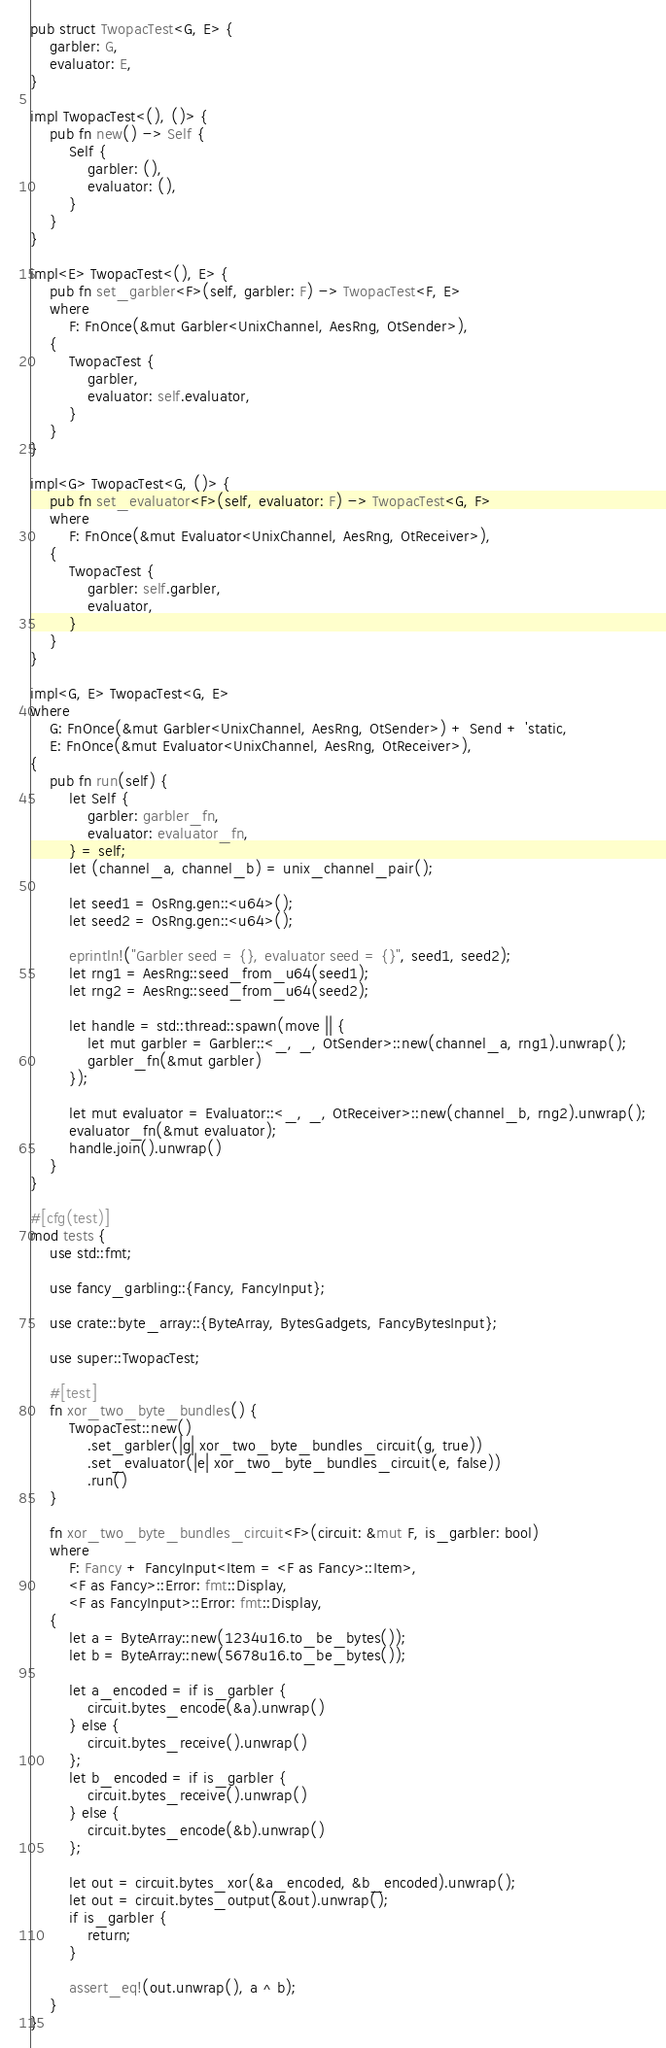Convert code to text. <code><loc_0><loc_0><loc_500><loc_500><_Rust_>pub struct TwopacTest<G, E> {
    garbler: G,
    evaluator: E,
}

impl TwopacTest<(), ()> {
    pub fn new() -> Self {
        Self {
            garbler: (),
            evaluator: (),
        }
    }
}

impl<E> TwopacTest<(), E> {
    pub fn set_garbler<F>(self, garbler: F) -> TwopacTest<F, E>
    where
        F: FnOnce(&mut Garbler<UnixChannel, AesRng, OtSender>),
    {
        TwopacTest {
            garbler,
            evaluator: self.evaluator,
        }
    }
}

impl<G> TwopacTest<G, ()> {
    pub fn set_evaluator<F>(self, evaluator: F) -> TwopacTest<G, F>
    where
        F: FnOnce(&mut Evaluator<UnixChannel, AesRng, OtReceiver>),
    {
        TwopacTest {
            garbler: self.garbler,
            evaluator,
        }
    }
}

impl<G, E> TwopacTest<G, E>
where
    G: FnOnce(&mut Garbler<UnixChannel, AesRng, OtSender>) + Send + 'static,
    E: FnOnce(&mut Evaluator<UnixChannel, AesRng, OtReceiver>),
{
    pub fn run(self) {
        let Self {
            garbler: garbler_fn,
            evaluator: evaluator_fn,
        } = self;
        let (channel_a, channel_b) = unix_channel_pair();

        let seed1 = OsRng.gen::<u64>();
        let seed2 = OsRng.gen::<u64>();

        eprintln!("Garbler seed = {}, evaluator seed = {}", seed1, seed2);
        let rng1 = AesRng::seed_from_u64(seed1);
        let rng2 = AesRng::seed_from_u64(seed2);

        let handle = std::thread::spawn(move || {
            let mut garbler = Garbler::<_, _, OtSender>::new(channel_a, rng1).unwrap();
            garbler_fn(&mut garbler)
        });

        let mut evaluator = Evaluator::<_, _, OtReceiver>::new(channel_b, rng2).unwrap();
        evaluator_fn(&mut evaluator);
        handle.join().unwrap()
    }
}

#[cfg(test)]
mod tests {
    use std::fmt;

    use fancy_garbling::{Fancy, FancyInput};

    use crate::byte_array::{ByteArray, BytesGadgets, FancyBytesInput};

    use super::TwopacTest;

    #[test]
    fn xor_two_byte_bundles() {
        TwopacTest::new()
            .set_garbler(|g| xor_two_byte_bundles_circuit(g, true))
            .set_evaluator(|e| xor_two_byte_bundles_circuit(e, false))
            .run()
    }

    fn xor_two_byte_bundles_circuit<F>(circuit: &mut F, is_garbler: bool)
    where
        F: Fancy + FancyInput<Item = <F as Fancy>::Item>,
        <F as Fancy>::Error: fmt::Display,
        <F as FancyInput>::Error: fmt::Display,
    {
        let a = ByteArray::new(1234u16.to_be_bytes());
        let b = ByteArray::new(5678u16.to_be_bytes());

        let a_encoded = if is_garbler {
            circuit.bytes_encode(&a).unwrap()
        } else {
            circuit.bytes_receive().unwrap()
        };
        let b_encoded = if is_garbler {
            circuit.bytes_receive().unwrap()
        } else {
            circuit.bytes_encode(&b).unwrap()
        };

        let out = circuit.bytes_xor(&a_encoded, &b_encoded).unwrap();
        let out = circuit.bytes_output(&out).unwrap();
        if is_garbler {
            return;
        }

        assert_eq!(out.unwrap(), a ^ b);
    }
}
</code> 